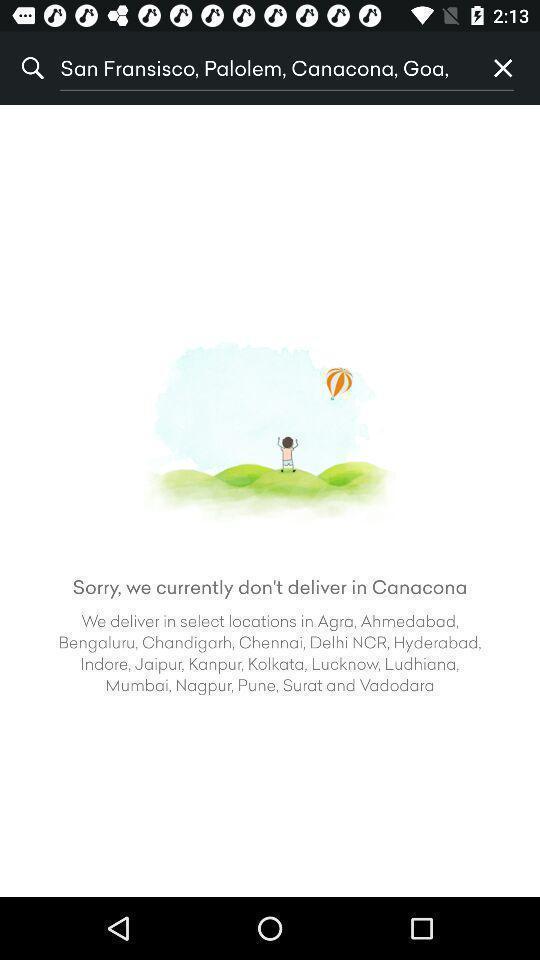Tell me about the visual elements in this screen capture. Screen displaying a search bar in a shopping application. 